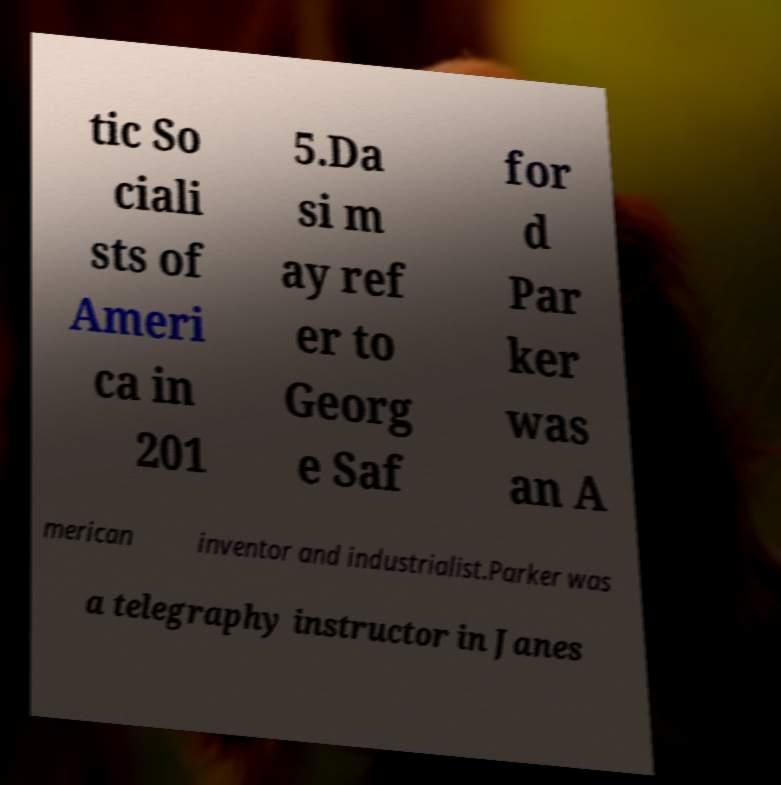Can you read and provide the text displayed in the image?This photo seems to have some interesting text. Can you extract and type it out for me? tic So ciali sts of Ameri ca in 201 5.Da si m ay ref er to Georg e Saf for d Par ker was an A merican inventor and industrialist.Parker was a telegraphy instructor in Janes 